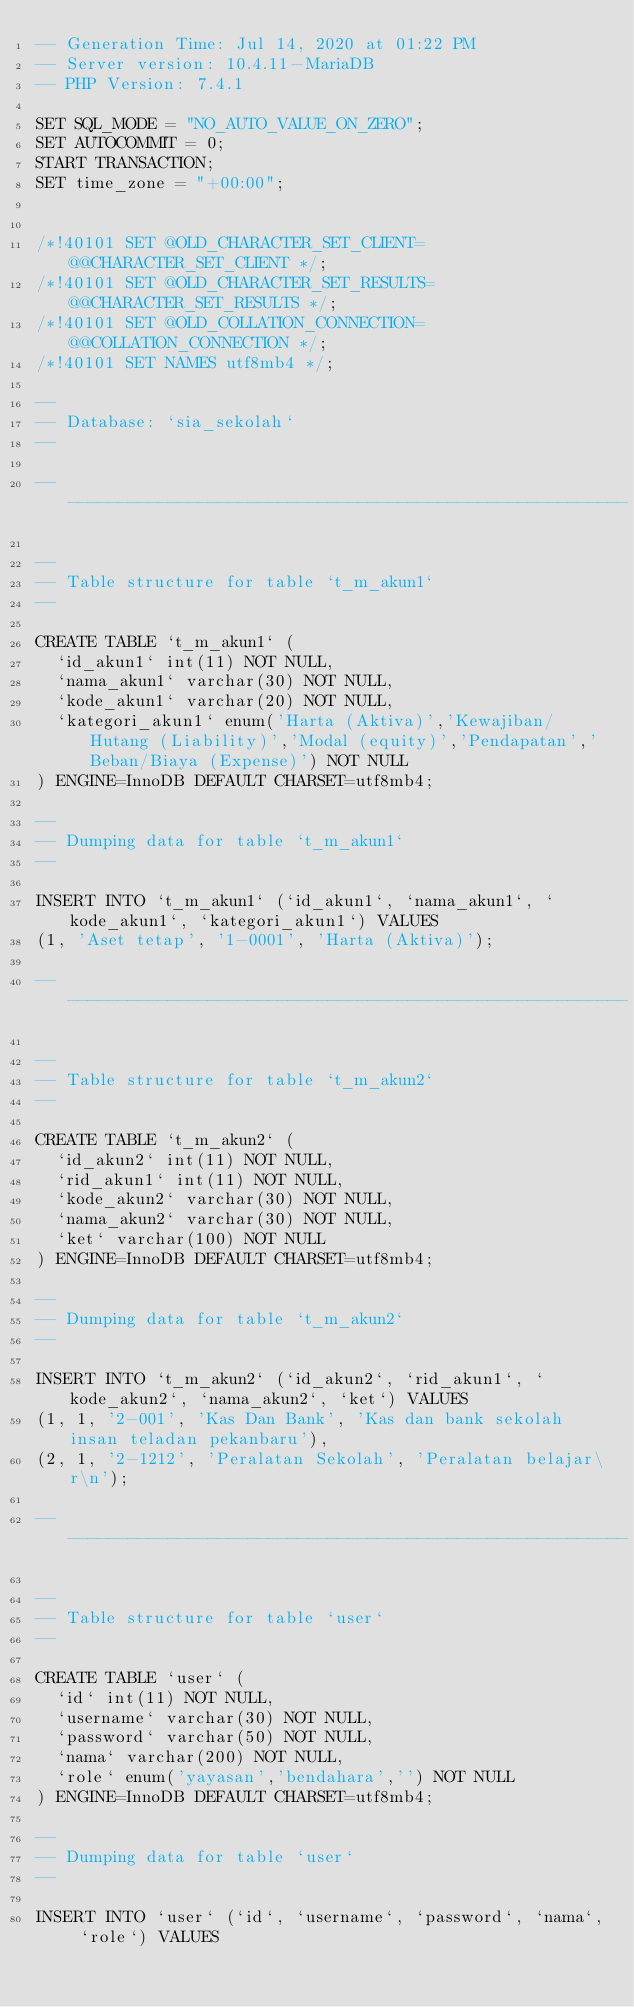Convert code to text. <code><loc_0><loc_0><loc_500><loc_500><_SQL_>-- Generation Time: Jul 14, 2020 at 01:22 PM
-- Server version: 10.4.11-MariaDB
-- PHP Version: 7.4.1

SET SQL_MODE = "NO_AUTO_VALUE_ON_ZERO";
SET AUTOCOMMIT = 0;
START TRANSACTION;
SET time_zone = "+00:00";


/*!40101 SET @OLD_CHARACTER_SET_CLIENT=@@CHARACTER_SET_CLIENT */;
/*!40101 SET @OLD_CHARACTER_SET_RESULTS=@@CHARACTER_SET_RESULTS */;
/*!40101 SET @OLD_COLLATION_CONNECTION=@@COLLATION_CONNECTION */;
/*!40101 SET NAMES utf8mb4 */;

--
-- Database: `sia_sekolah`
--

-- --------------------------------------------------------

--
-- Table structure for table `t_m_akun1`
--

CREATE TABLE `t_m_akun1` (
  `id_akun1` int(11) NOT NULL,
  `nama_akun1` varchar(30) NOT NULL,
  `kode_akun1` varchar(20) NOT NULL,
  `kategori_akun1` enum('Harta (Aktiva)','Kewajiban/Hutang (Liability)','Modal (equity)','Pendapatan','Beban/Biaya (Expense)') NOT NULL
) ENGINE=InnoDB DEFAULT CHARSET=utf8mb4;

--
-- Dumping data for table `t_m_akun1`
--

INSERT INTO `t_m_akun1` (`id_akun1`, `nama_akun1`, `kode_akun1`, `kategori_akun1`) VALUES
(1, 'Aset tetap', '1-0001', 'Harta (Aktiva)');

-- --------------------------------------------------------

--
-- Table structure for table `t_m_akun2`
--

CREATE TABLE `t_m_akun2` (
  `id_akun2` int(11) NOT NULL,
  `rid_akun1` int(11) NOT NULL,
  `kode_akun2` varchar(30) NOT NULL,
  `nama_akun2` varchar(30) NOT NULL,
  `ket` varchar(100) NOT NULL
) ENGINE=InnoDB DEFAULT CHARSET=utf8mb4;

--
-- Dumping data for table `t_m_akun2`
--

INSERT INTO `t_m_akun2` (`id_akun2`, `rid_akun1`, `kode_akun2`, `nama_akun2`, `ket`) VALUES
(1, 1, '2-001', 'Kas Dan Bank', 'Kas dan bank sekolah insan teladan pekanbaru'),
(2, 1, '2-1212', 'Peralatan Sekolah', 'Peralatan belajar\r\n');

-- --------------------------------------------------------

--
-- Table structure for table `user`
--

CREATE TABLE `user` (
  `id` int(11) NOT NULL,
  `username` varchar(30) NOT NULL,
  `password` varchar(50) NOT NULL,
  `nama` varchar(200) NOT NULL,
  `role` enum('yayasan','bendahara','') NOT NULL
) ENGINE=InnoDB DEFAULT CHARSET=utf8mb4;

--
-- Dumping data for table `user`
--

INSERT INTO `user` (`id`, `username`, `password`, `nama`, `role`) VALUES</code> 